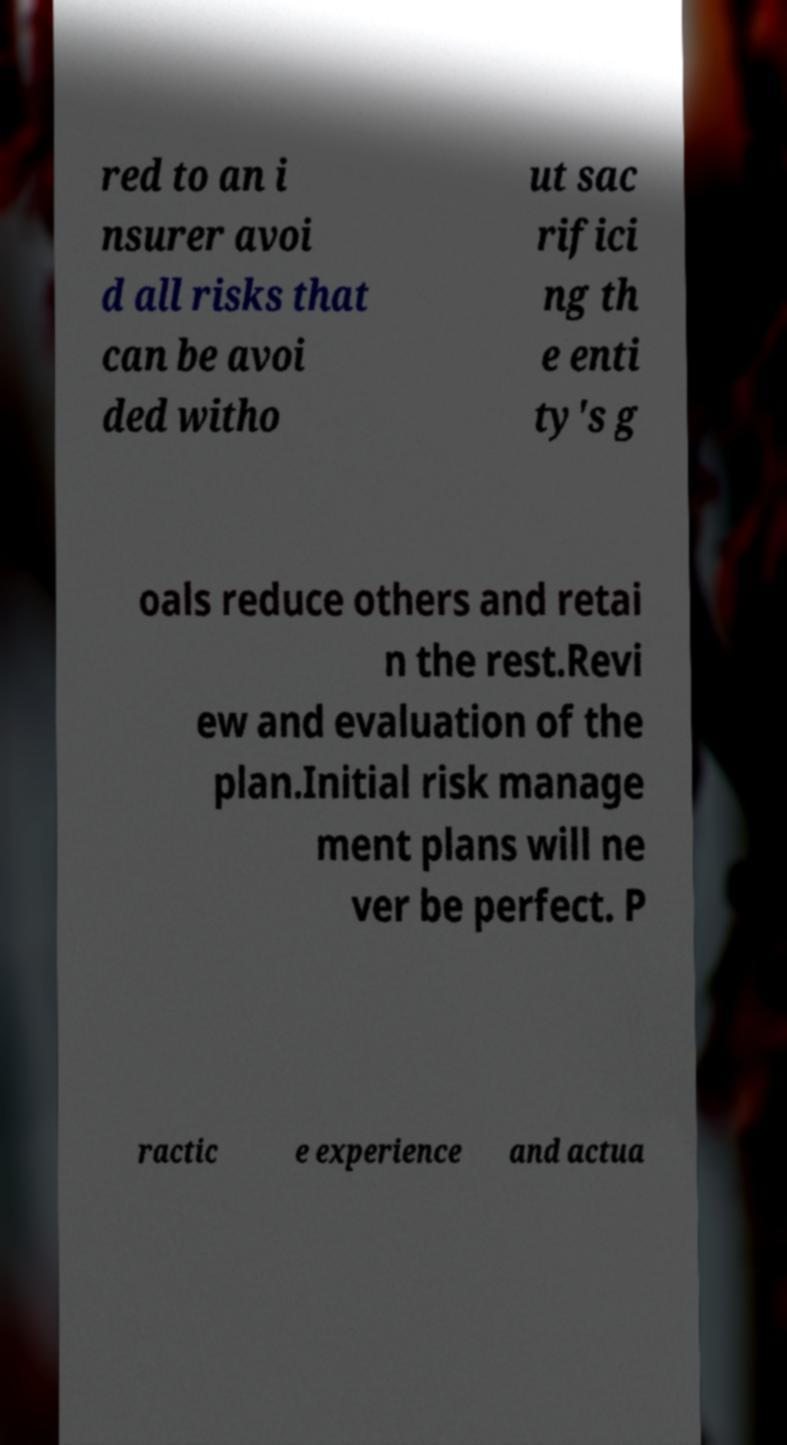Please identify and transcribe the text found in this image. red to an i nsurer avoi d all risks that can be avoi ded witho ut sac rifici ng th e enti ty's g oals reduce others and retai n the rest.Revi ew and evaluation of the plan.Initial risk manage ment plans will ne ver be perfect. P ractic e experience and actua 